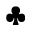Convert formula to latex. <formula><loc_0><loc_0><loc_500><loc_500>\clubsuit</formula> 